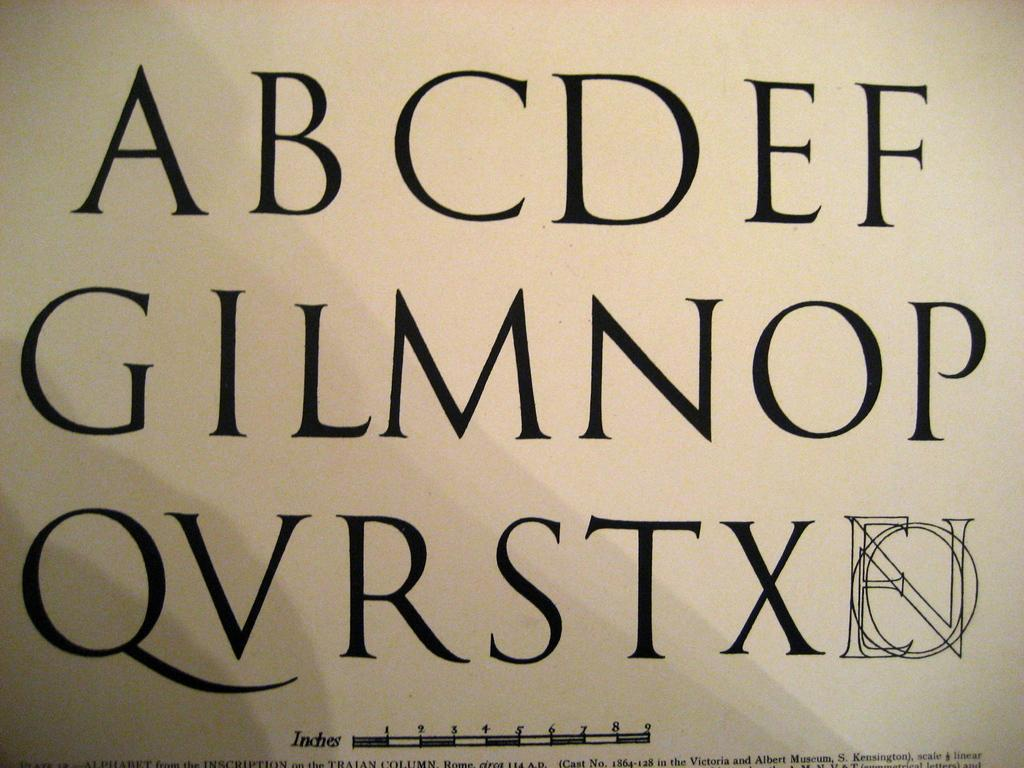Provide a one-sentence caption for the provided image. An Alphabet chart is missing some letters such as H, J, and K and other letters are out of order. 